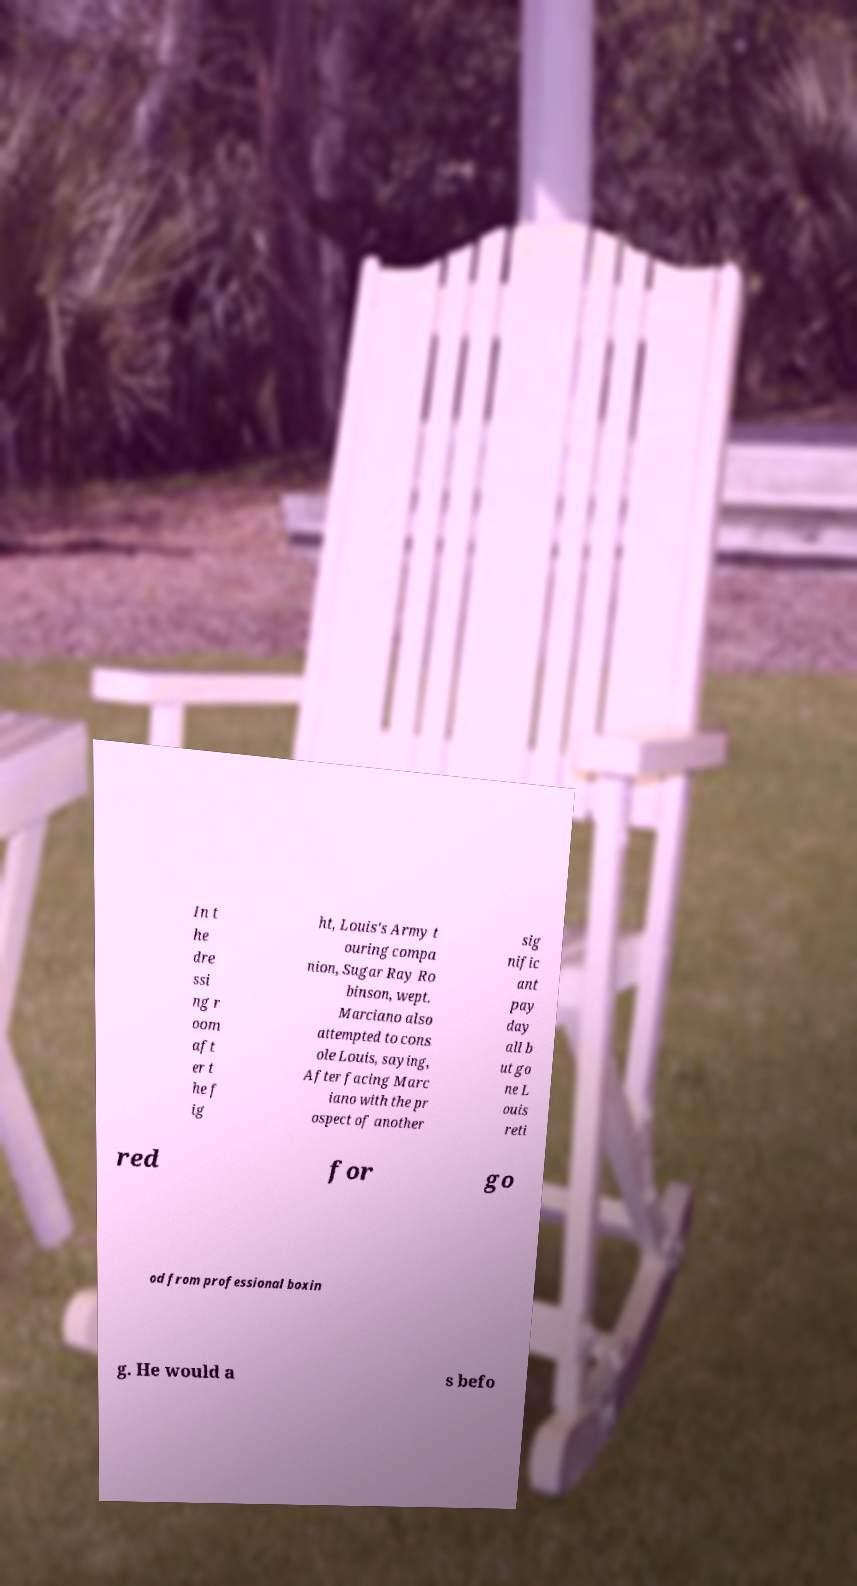Can you read and provide the text displayed in the image?This photo seems to have some interesting text. Can you extract and type it out for me? In t he dre ssi ng r oom aft er t he f ig ht, Louis's Army t ouring compa nion, Sugar Ray Ro binson, wept. Marciano also attempted to cons ole Louis, saying, After facing Marc iano with the pr ospect of another sig nific ant pay day all b ut go ne L ouis reti red for go od from professional boxin g. He would a s befo 